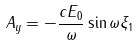<formula> <loc_0><loc_0><loc_500><loc_500>A _ { y } = - \frac { c E _ { 0 } } { \omega } \sin \omega \xi _ { 1 }</formula> 